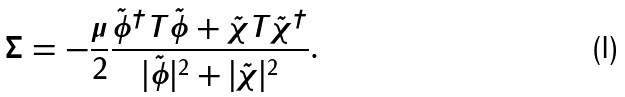<formula> <loc_0><loc_0><loc_500><loc_500>\Sigma = - \frac { \mu } { 2 } \frac { \tilde { \phi } ^ { \dagger } T \tilde { \phi } + \tilde { \chi } T \tilde { \chi } ^ { \dagger } } { | \tilde { \phi } | ^ { 2 } + | \tilde { \chi } | ^ { 2 } } .</formula> 